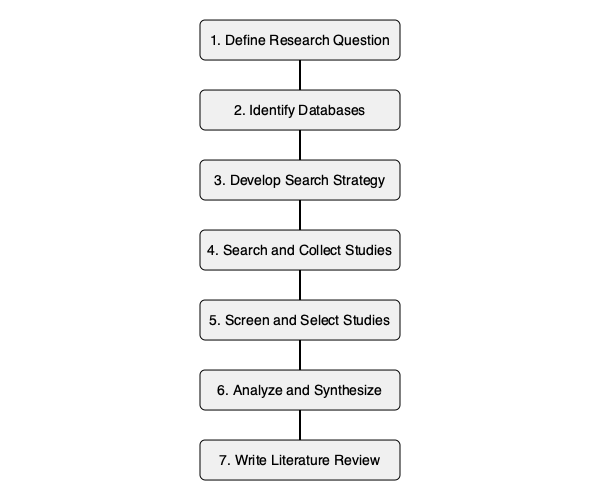In the flowchart depicting the literature review process, which step immediately follows the development of a search strategy? To answer this question, let's examine the flowchart step-by-step:

1. The process begins with "Define Research Question."
2. Next, we "Identify Databases" to search for relevant literature.
3. The third step is to "Develop Search Strategy," which involves creating appropriate search terms and criteria.
4. Immediately following the development of the search strategy, we see "Search and Collect Studies." This is the step where the researcher actually executes the search strategy developed in the previous step.
5. After collecting studies, the next steps are "Screen and Select Studies," "Analyze and Synthesize," and finally "Write Literature Review."

Therefore, the step that immediately follows the development of a search strategy is to search and collect studies using that strategy.
Answer: Search and Collect Studies 